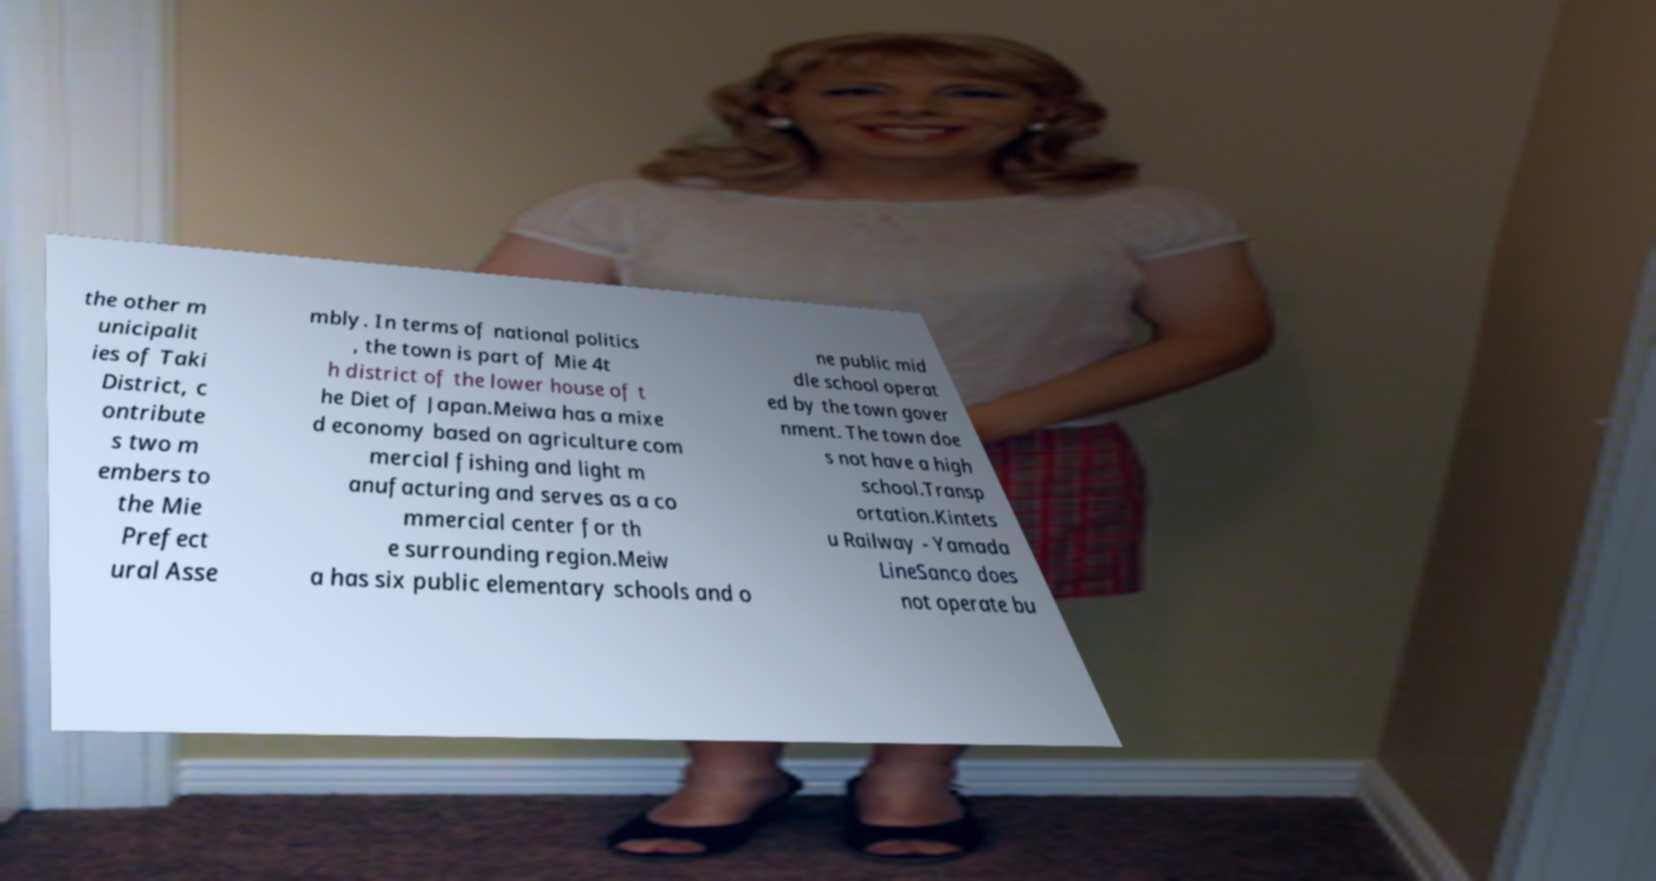What messages or text are displayed in this image? I need them in a readable, typed format. the other m unicipalit ies of Taki District, c ontribute s two m embers to the Mie Prefect ural Asse mbly. In terms of national politics , the town is part of Mie 4t h district of the lower house of t he Diet of Japan.Meiwa has a mixe d economy based on agriculture com mercial fishing and light m anufacturing and serves as a co mmercial center for th e surrounding region.Meiw a has six public elementary schools and o ne public mid dle school operat ed by the town gover nment. The town doe s not have a high school.Transp ortation.Kintets u Railway - Yamada LineSanco does not operate bu 